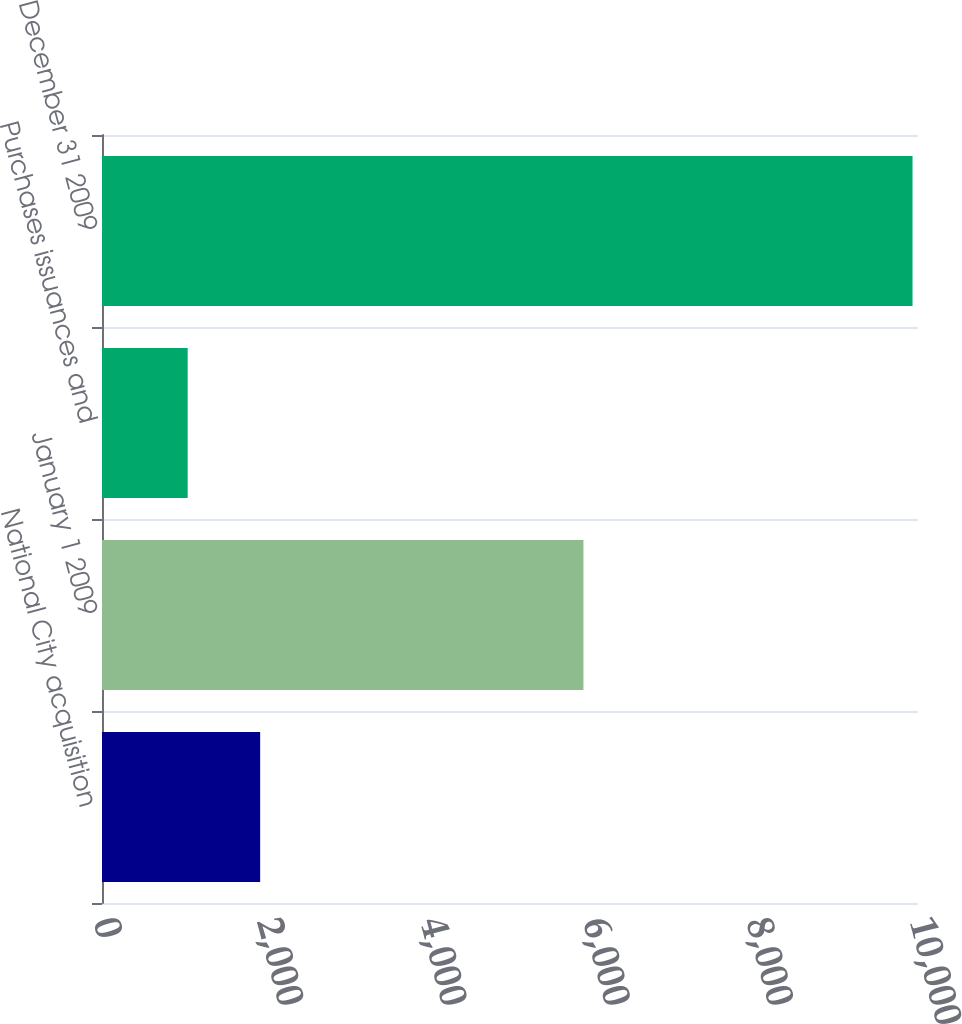Convert chart to OTSL. <chart><loc_0><loc_0><loc_500><loc_500><bar_chart><fcel>National City acquisition<fcel>January 1 2009<fcel>Purchases issuances and<fcel>December 31 2009<nl><fcel>1938.3<fcel>5900<fcel>1050<fcel>9933<nl></chart> 